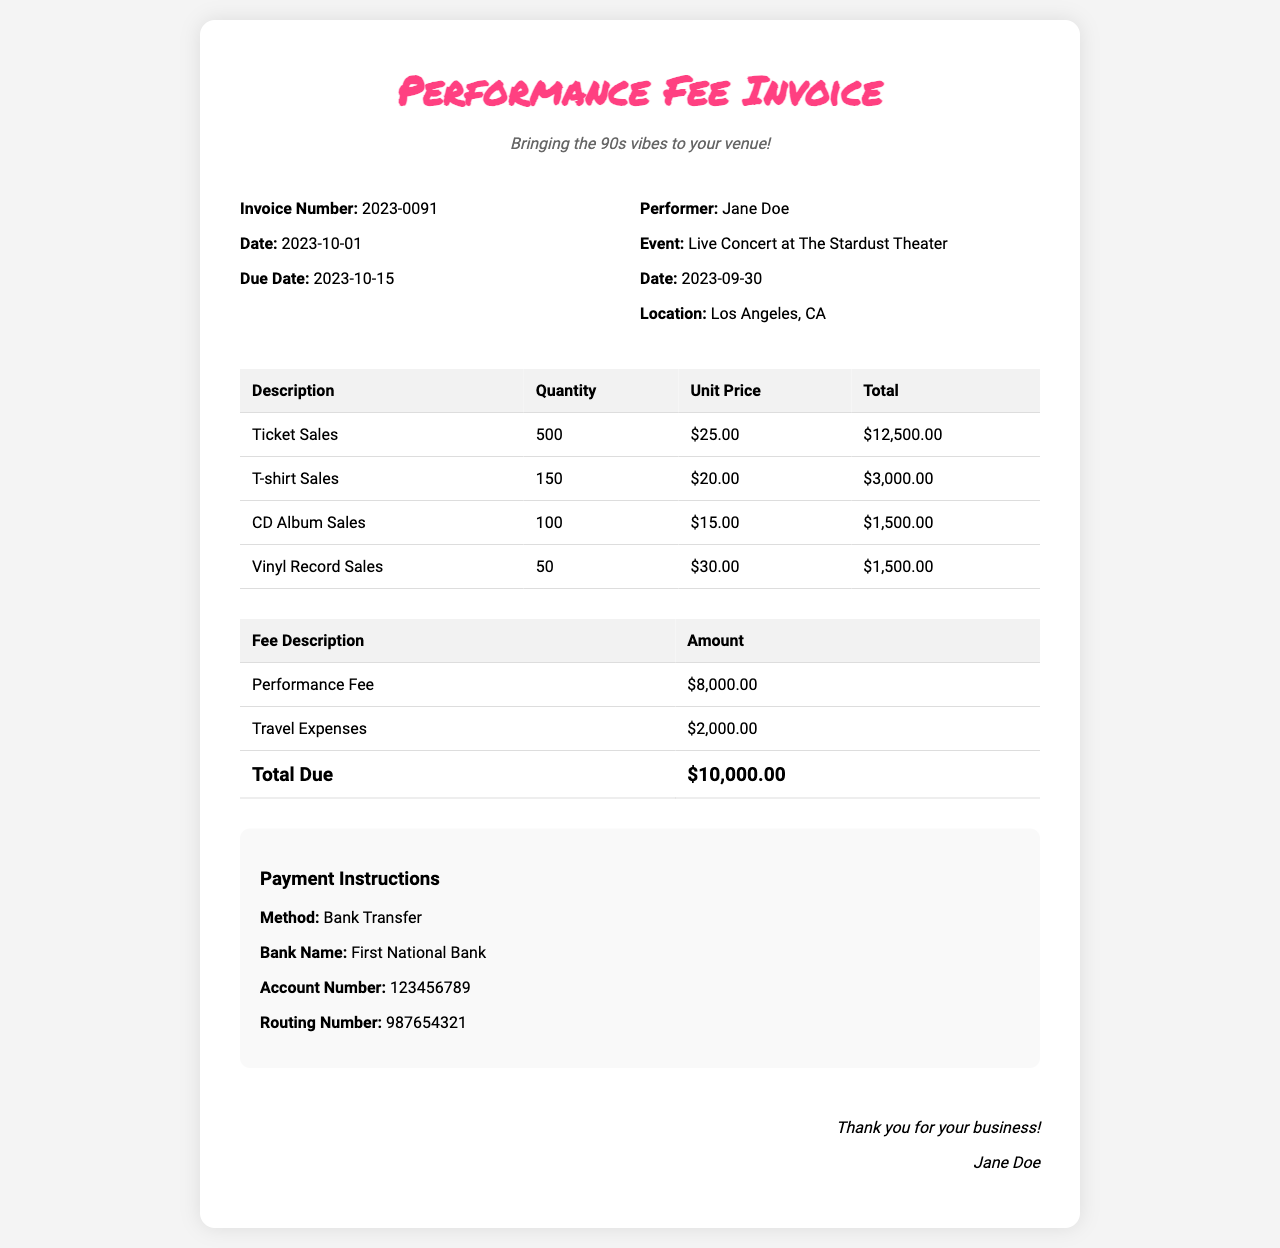what is the invoice number? The invoice number is listed clearly at the top of the invoice details section.
Answer: 2023-0091 what is the date of the performance? The date of the performance is mentioned in the event details section.
Answer: 2023-09-30 how many tickets were sold? The number of tickets sold is shown in the ticket sales row of the revenue table.
Answer: 500 what is the total revenue from merchandise? The total revenue from merchandise includes T-shirt, CD album, and vinyl sales.
Answer: $6,000.00 what is the performance fee amount? The performance fee amount is stated in the fee breakdown section of the invoice.
Answer: $8,000.00 what is the total amount due? The total amount due is calculated and presented at the bottom of the fee breakdown table.
Answer: $10,000.00 who is the performer for this event? The performer's name is provided in the event details portion of the invoice.
Answer: Jane Doe what is the location of the concert? The location of the concert is stated in the event details section of the invoice.
Answer: Los Angeles, CA how much were travel expenses? The travel expenses are listed separately in the fee breakdown section.
Answer: $2,000.00 